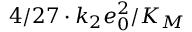Convert formula to latex. <formula><loc_0><loc_0><loc_500><loc_500>4 / 2 7 \cdot k _ { 2 } e _ { 0 } ^ { 2 } / K _ { M }</formula> 